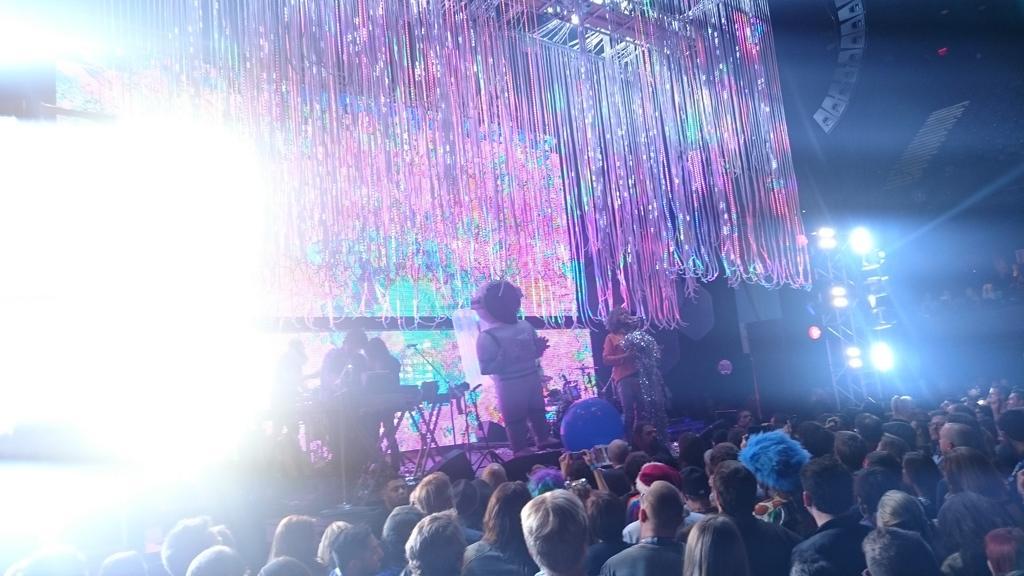Describe this image in one or two sentences. In the foreground of this image, on the bottom, there is the crowd standing. On the left, there is a light focus. In the background, on the stage, there are decorations, screen, persons standing, a table and a mic. On the right, there is a light and the dark background. 